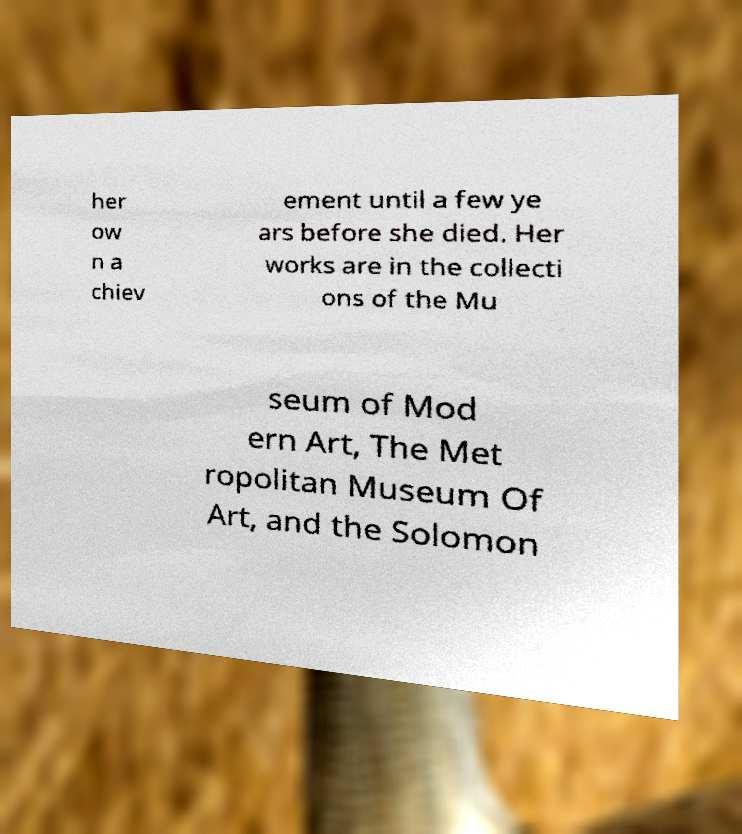Please read and relay the text visible in this image. What does it say? her ow n a chiev ement until a few ye ars before she died. Her works are in the collecti ons of the Mu seum of Mod ern Art, The Met ropolitan Museum Of Art, and the Solomon 